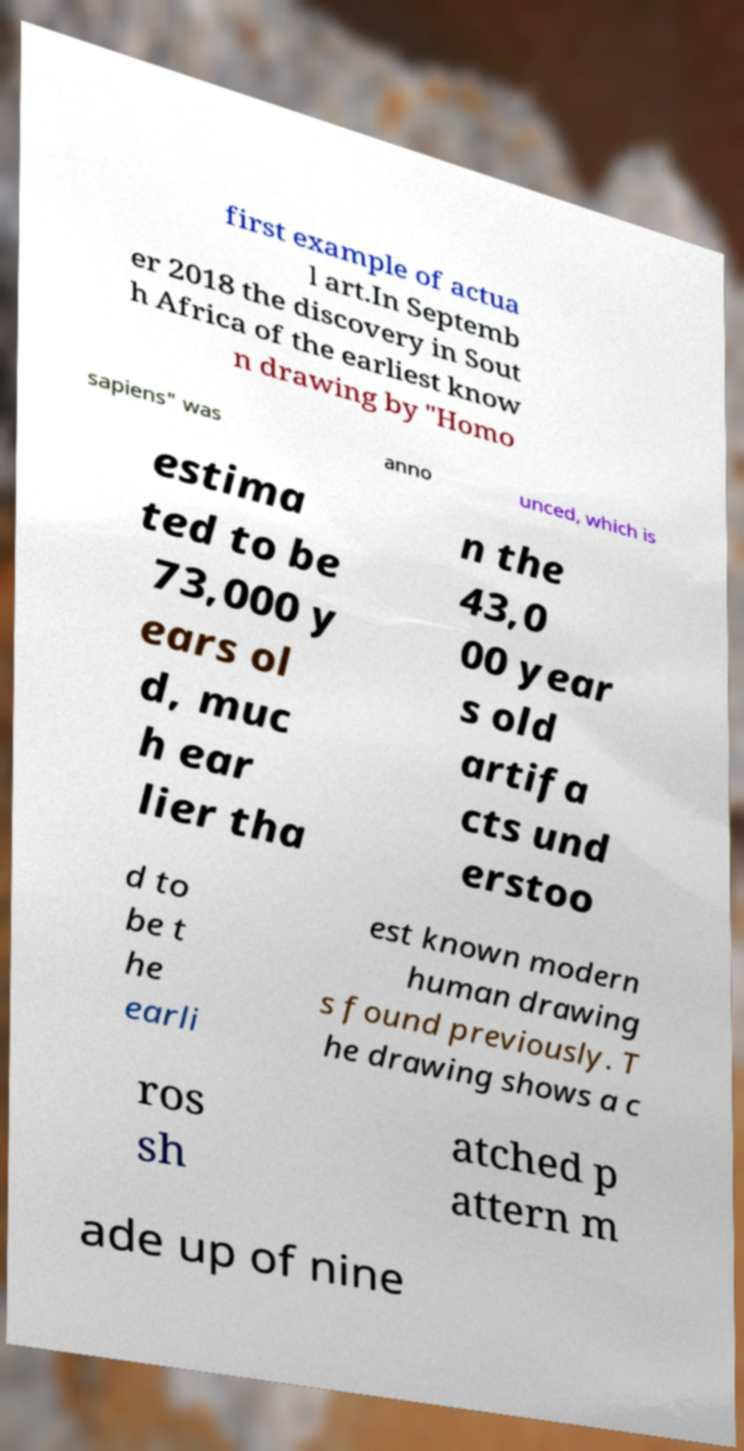Please identify and transcribe the text found in this image. first example of actua l art.In Septemb er 2018 the discovery in Sout h Africa of the earliest know n drawing by "Homo sapiens" was anno unced, which is estima ted to be 73,000 y ears ol d, muc h ear lier tha n the 43,0 00 year s old artifa cts und erstoo d to be t he earli est known modern human drawing s found previously. T he drawing shows a c ros sh atched p attern m ade up of nine 